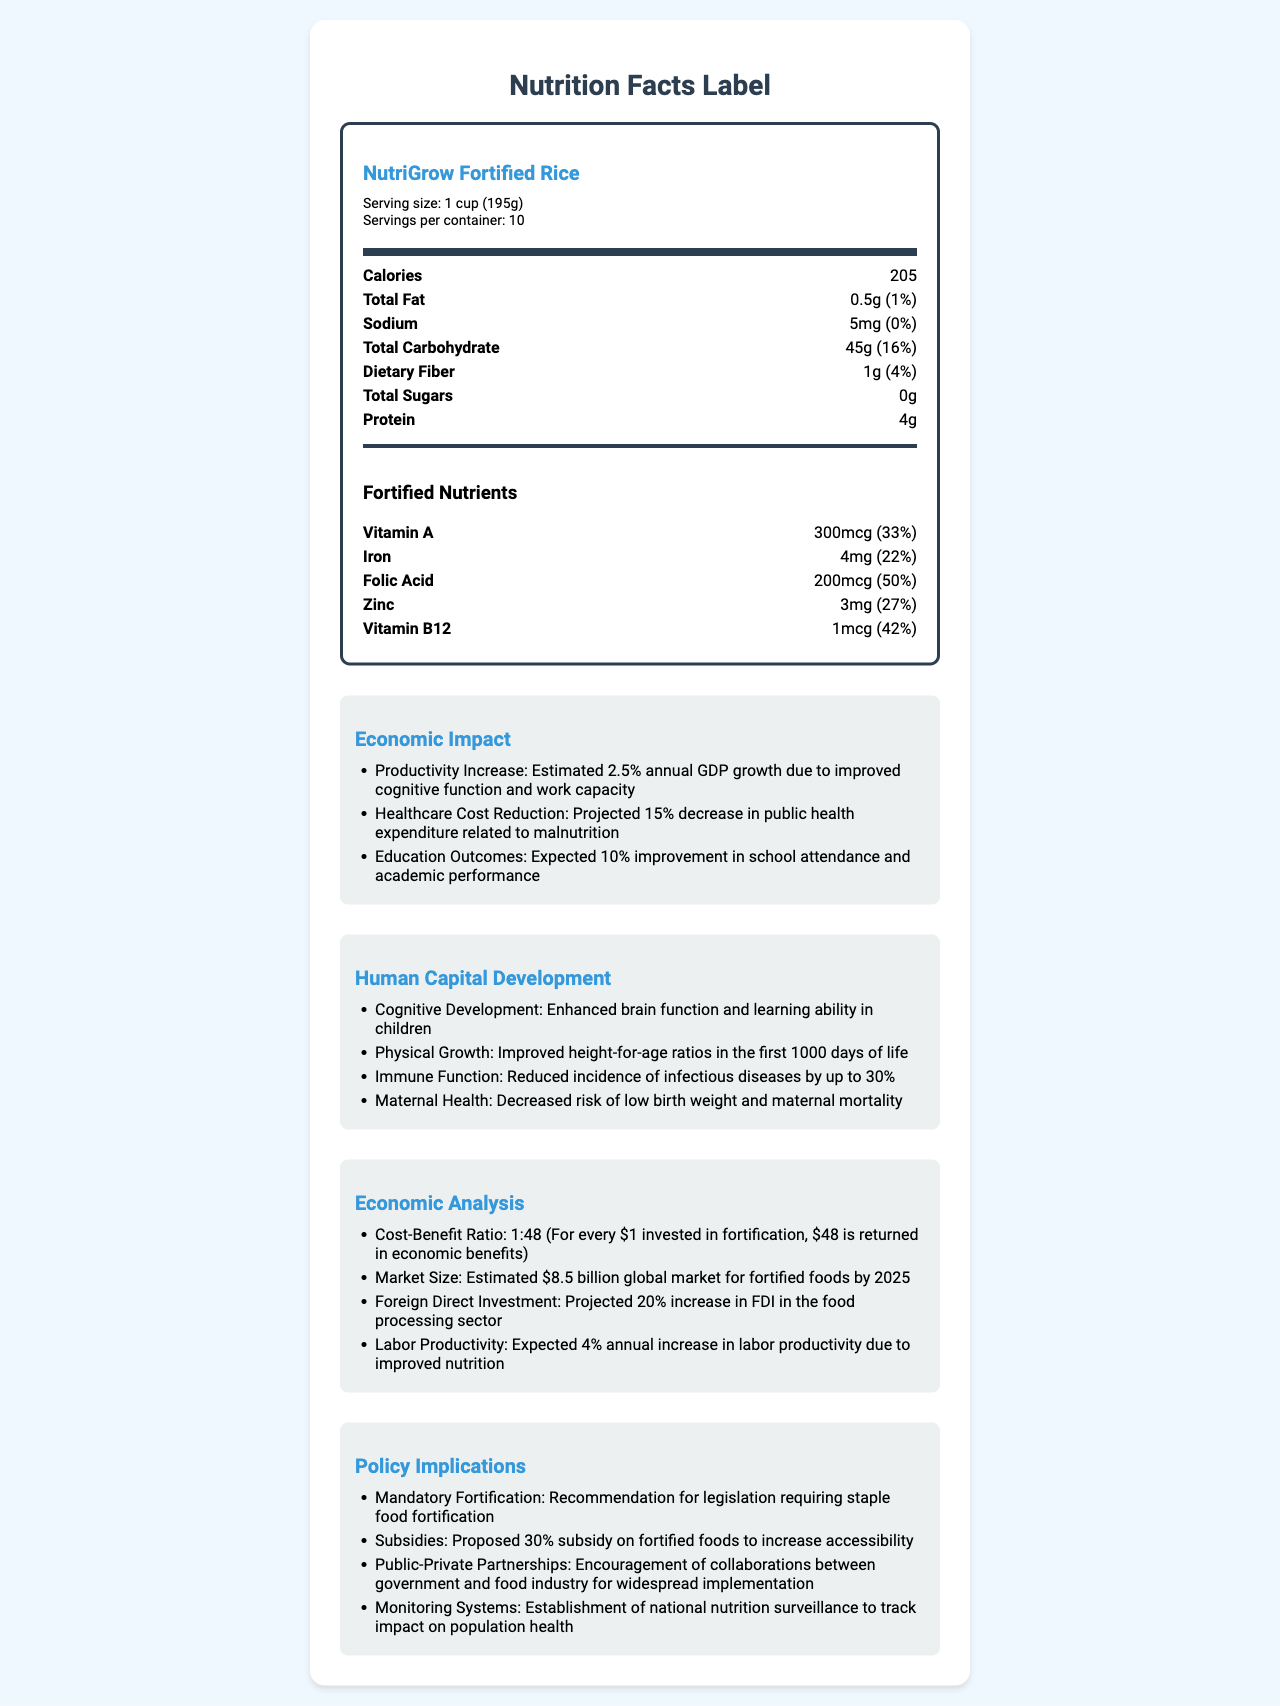what is the serving size for NutriGrow Fortified Rice? The document lists the serving size for NutriGrow Fortified Rice as 1 cup (195g).
Answer: 1 cup (195g) how many calories are in a serving of NutriGrow Fortified Rice? The document specifies that each serving of NutriGrow Fortified Rice contains 205 calories.
Answer: 205 what is the daily value percentage of Vitamin A in a serving? The fortified nutrients section states that a serving contains 300mcg of Vitamin A, which is 33% of the daily value.
Answer: 33% how does NutriGrow Fortified Rice impact healthcare costs? The economic impact section mentions a projected 15% decrease in public health expenditure related to malnutrition due to NutriGrow Fortified Rice.
Answer: Projected 15% decrease in public health expenditure related to malnutrition what is the projected market size for fortified foods by 2025? The economic analysis section reports an estimated $8.5 billion global market for fortified foods by 2025.
Answer: $8.5 billion what is the expected improvement in school attendance and academic performance due to NutriGrow Fortified Rice? A. 5% B. 10% C. 15% D. 20% The economic impact section states an expected 10% improvement in school attendance and academic performance.
Answer: B. 10% what is the cost-benefit ratio for NutriGrow Fortified Rice? A. 1:20 B. 1:30 C. 1:40 D. 1:48 The economic analysis section specifies a cost-benefit ratio of 1:48 (for every $1 invested, $48 is returned in economic benefits).
Answer: D. 1:48 does NutriGrow Fortified Rice contain any total sugars? The label indicates that the total sugars amount is 0g.
Answer: No is mandatory fortification recommended for staple foods? The policy implications section recommends legislation requiring staple food fortification.
Answer: Yes summarize the main economic and health benefits of NutriGrow Fortified Rice. The document highlights various economic and health benefits, including improved human capital development and significant economic returns from investing in fortified foods.
Answer: NutriGrow Fortified Rice improves cognitive function, physical growth, immune function, and maternal health, leading to increased productivity, reduced healthcare costs, and better educational outcomes. The economic benefits include a cost-benefit ratio of 1:48, projected market growth, increased foreign direct investment, and enhanced labor productivity. what are the sources of the data on economic impact? The document does not provide specific sources for the data on economic impact.
Answer: Not enough information 